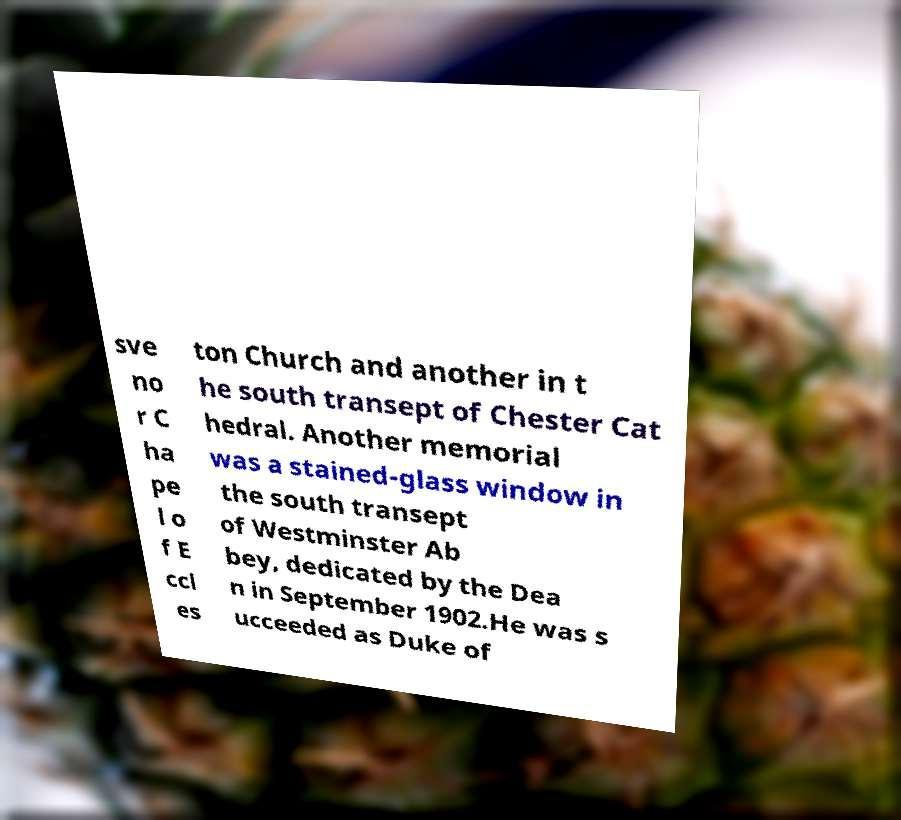There's text embedded in this image that I need extracted. Can you transcribe it verbatim? sve no r C ha pe l o f E ccl es ton Church and another in t he south transept of Chester Cat hedral. Another memorial was a stained-glass window in the south transept of Westminster Ab bey, dedicated by the Dea n in September 1902.He was s ucceeded as Duke of 